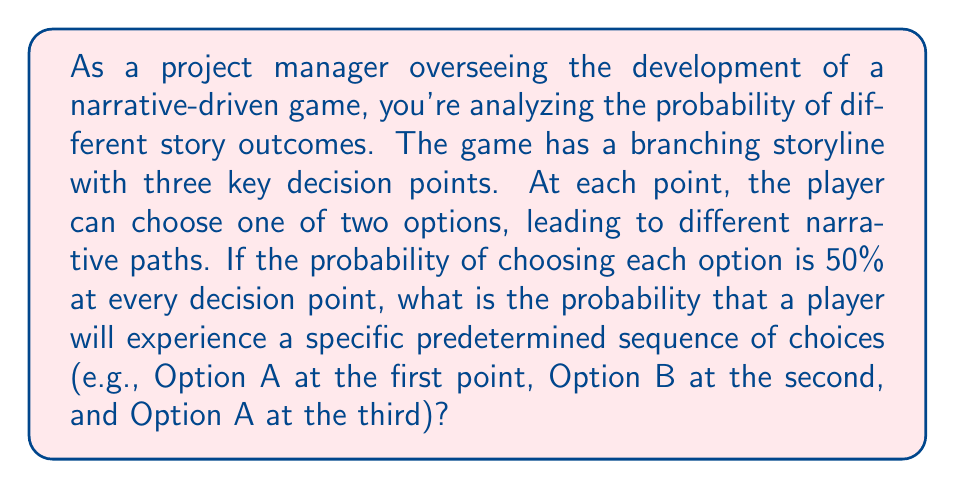Provide a solution to this math problem. Let's approach this step-by-step:

1) First, we need to understand that each decision point is an independent event. The choice made at one point doesn't affect the probabilities at subsequent points.

2) At each decision point, the probability of choosing either option is 50%, or $\frac{1}{2}$.

3) We're looking for the probability of a specific sequence of choices. In probability theory, when we want all of a series of independent events to occur, we multiply their individual probabilities.

4) The sequence we're calculating the probability for is:
   - Option A at the first point (probability $\frac{1}{2}$)
   - Option B at the second point (probability $\frac{1}{2}$)
   - Option A at the third point (probability $\frac{1}{2}$)

5) To calculate the probability of this specific sequence, we multiply these probabilities:

   $$P(\text{sequence}) = \frac{1}{2} \times \frac{1}{2} \times \frac{1}{2} = \frac{1}{8} = 0.125$$

6) This can also be written as:

   $$P(\text{sequence}) = (\frac{1}{2})^3 = \frac{1}{8} = 0.125$$

   Because we're multiplying $\frac{1}{2}$ by itself 3 times (once for each decision point).
Answer: The probability of a player experiencing this specific predetermined sequence of choices is $\frac{1}{8}$ or 0.125 or 12.5%. 